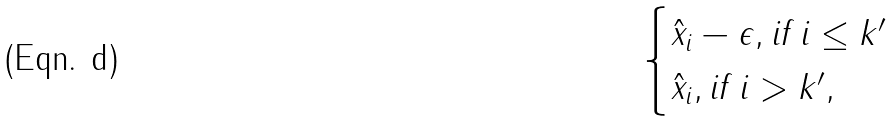<formula> <loc_0><loc_0><loc_500><loc_500>\begin{cases} \hat { x } _ { i } - \epsilon , \text {if $i\leq k^{\prime}$} \\ \hat { x } _ { i } , \text {if $i>k^{\prime}$} , \end{cases}</formula> 